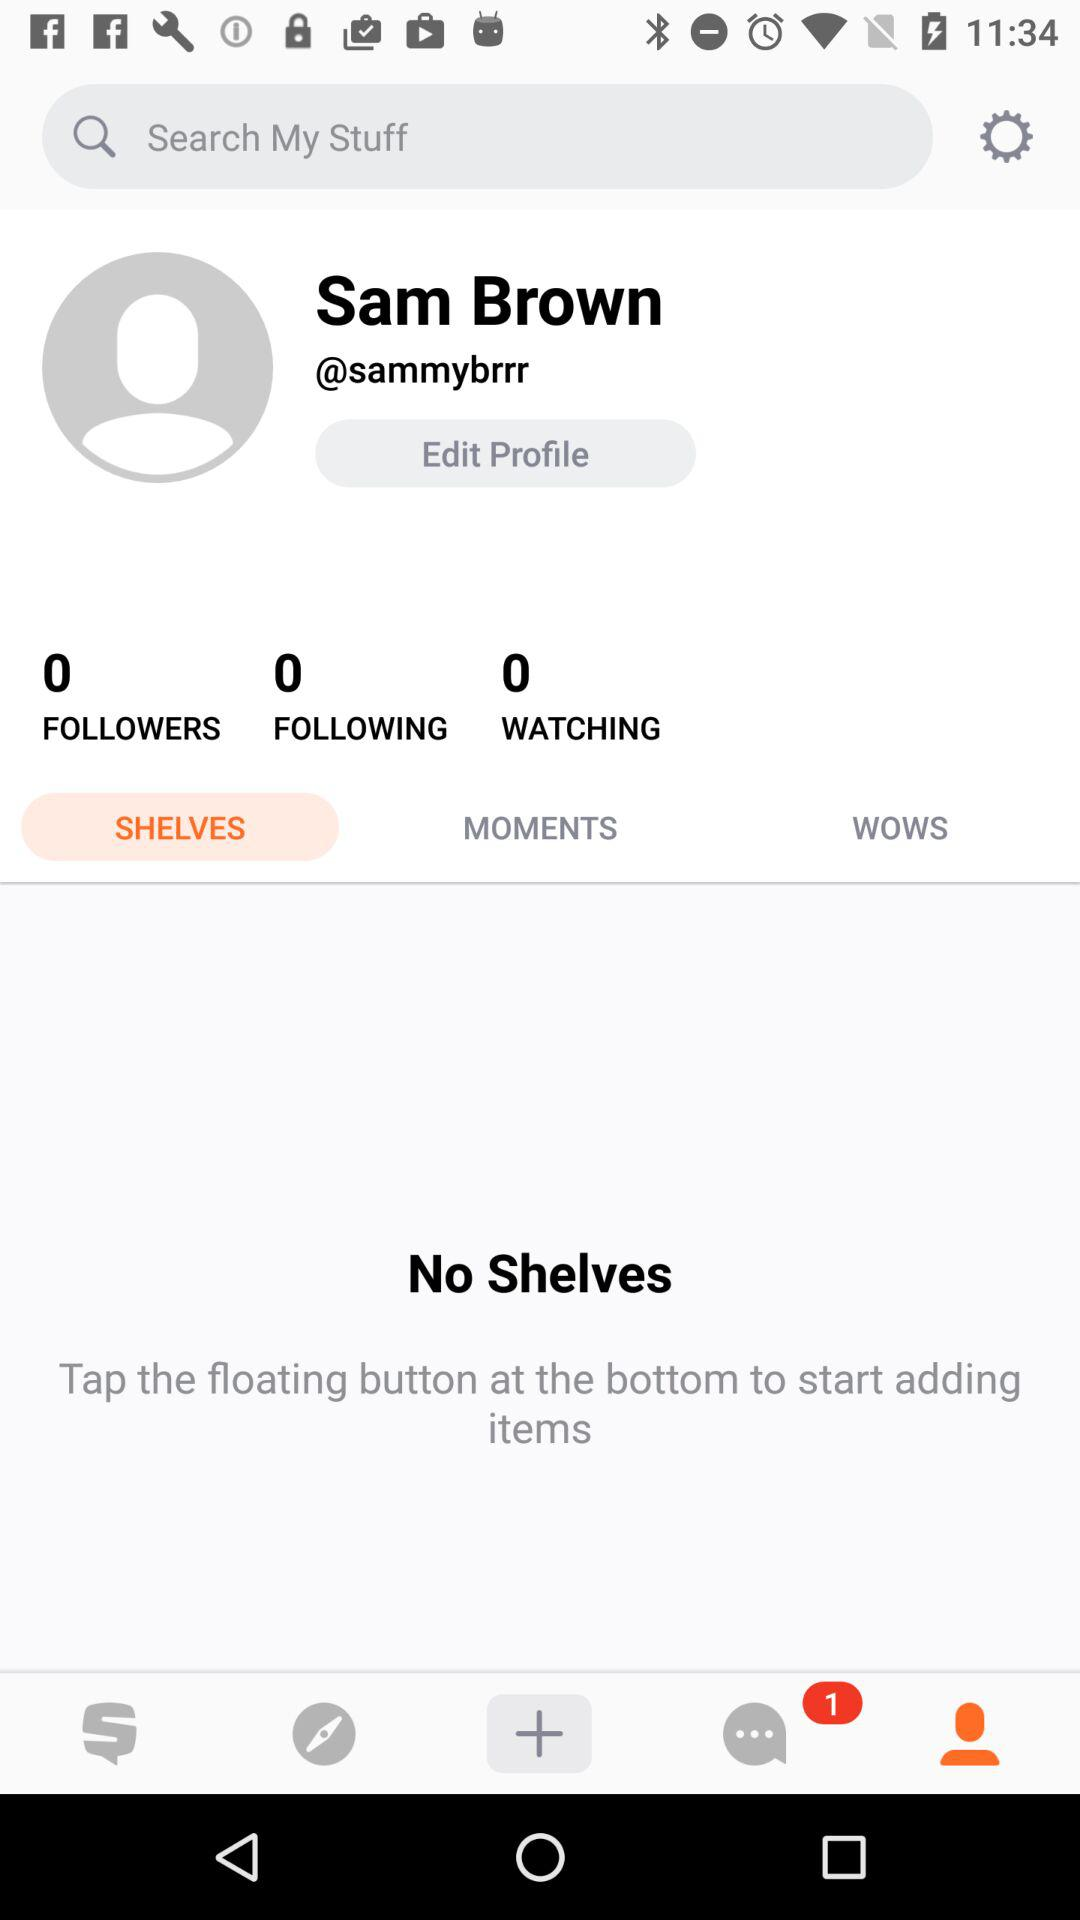How many followers are there? There are 0 followers. 